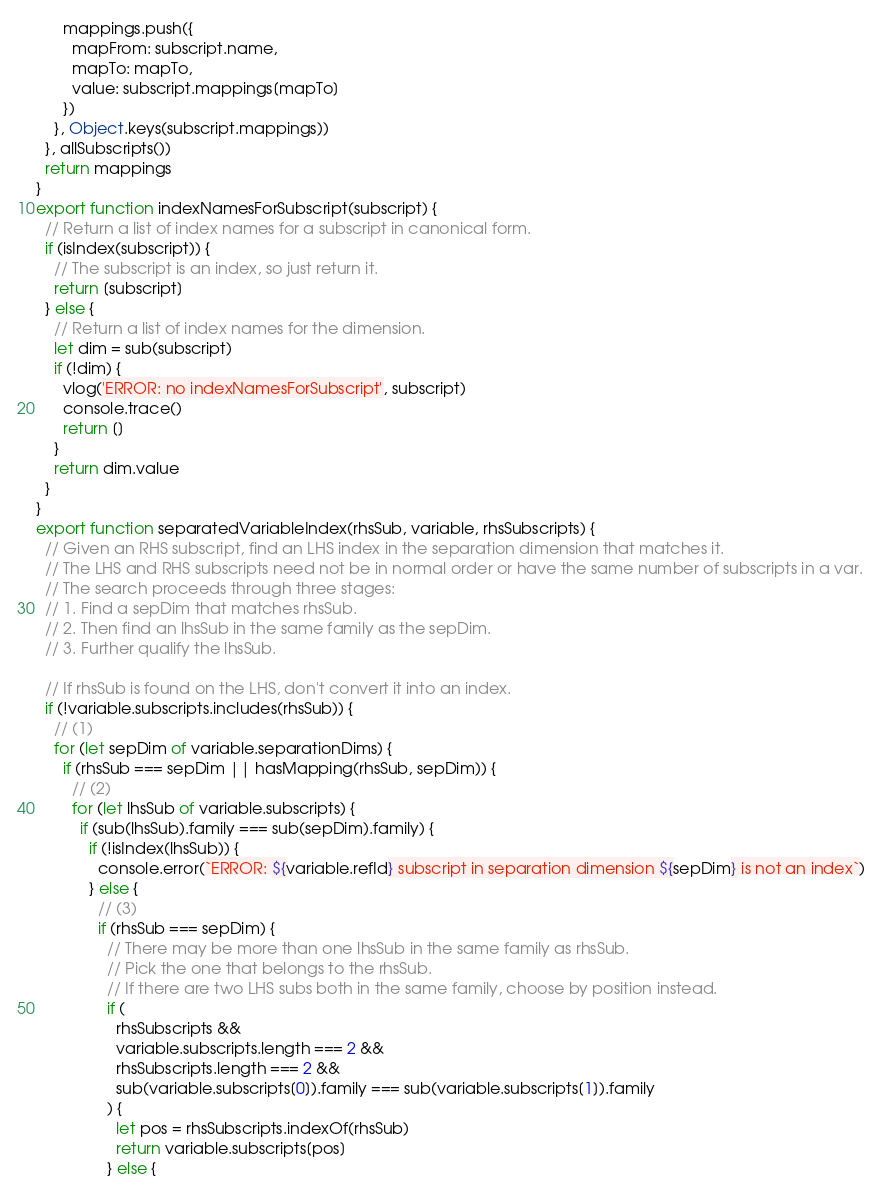<code> <loc_0><loc_0><loc_500><loc_500><_JavaScript_>      mappings.push({
        mapFrom: subscript.name,
        mapTo: mapTo,
        value: subscript.mappings[mapTo]
      })
    }, Object.keys(subscript.mappings))
  }, allSubscripts())
  return mappings
}
export function indexNamesForSubscript(subscript) {
  // Return a list of index names for a subscript in canonical form.
  if (isIndex(subscript)) {
    // The subscript is an index, so just return it.
    return [subscript]
  } else {
    // Return a list of index names for the dimension.
    let dim = sub(subscript)
    if (!dim) {
      vlog('ERROR: no indexNamesForSubscript', subscript)
      console.trace()
      return []
    }
    return dim.value
  }
}
export function separatedVariableIndex(rhsSub, variable, rhsSubscripts) {
  // Given an RHS subscript, find an LHS index in the separation dimension that matches it.
  // The LHS and RHS subscripts need not be in normal order or have the same number of subscripts in a var.
  // The search proceeds through three stages:
  // 1. Find a sepDim that matches rhsSub.
  // 2. Then find an lhsSub in the same family as the sepDim.
  // 3. Further qualify the lhsSub.

  // If rhsSub is found on the LHS, don't convert it into an index.
  if (!variable.subscripts.includes(rhsSub)) {
    // (1)
    for (let sepDim of variable.separationDims) {
      if (rhsSub === sepDim || hasMapping(rhsSub, sepDim)) {
        // (2)
        for (let lhsSub of variable.subscripts) {
          if (sub(lhsSub).family === sub(sepDim).family) {
            if (!isIndex(lhsSub)) {
              console.error(`ERROR: ${variable.refId} subscript in separation dimension ${sepDim} is not an index`)
            } else {
              // (3)
              if (rhsSub === sepDim) {
                // There may be more than one lhsSub in the same family as rhsSub.
                // Pick the one that belongs to the rhsSub.
                // If there are two LHS subs both in the same family, choose by position instead.
                if (
                  rhsSubscripts &&
                  variable.subscripts.length === 2 &&
                  rhsSubscripts.length === 2 &&
                  sub(variable.subscripts[0]).family === sub(variable.subscripts[1]).family
                ) {
                  let pos = rhsSubscripts.indexOf(rhsSub)
                  return variable.subscripts[pos]
                } else {</code> 